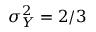<formula> <loc_0><loc_0><loc_500><loc_500>\sigma _ { Y } ^ { 2 } = 2 / 3</formula> 